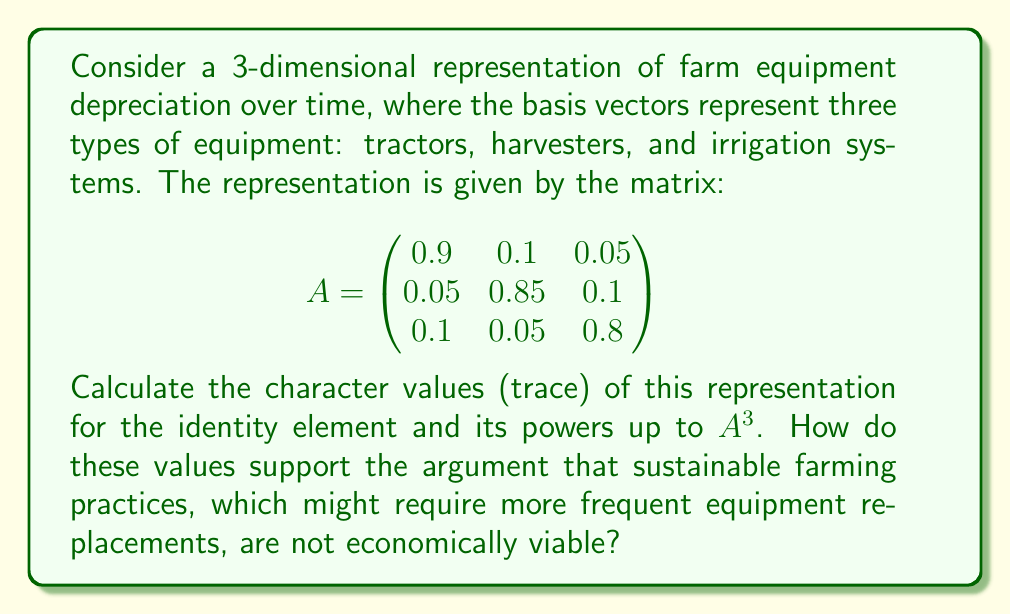Teach me how to tackle this problem. To calculate the character values, we need to find the trace of the matrix $A$ and its powers up to $A^3$. The trace is the sum of the elements on the main diagonal.

Step 1: Calculate $\text{Tr}(A)$
$$\text{Tr}(A) = 0.9 + 0.85 + 0.8 = 2.55$$

Step 2: Calculate $A^2$
$$A^2 = \begin{pmatrix}
0.9 & 0.1 & 0.05 \\
0.05 & 0.85 & 0.1 \\
0.1 & 0.05 & 0.8
\end{pmatrix} \times \begin{pmatrix}
0.9 & 0.1 & 0.05 \\
0.05 & 0.85 & 0.1 \\
0.1 & 0.05 & 0.8
\end{pmatrix}$$

$$A^2 = \begin{pmatrix}
0.8175 & 0.1775 & 0.1 \\
0.0925 & 0.7325 & 0.17 \\
0.175 & 0.0925 & 0.655
\end{pmatrix}$$

Step 3: Calculate $\text{Tr}(A^2)$
$$\text{Tr}(A^2) = 0.8175 + 0.7325 + 0.655 = 2.205$$

Step 4: Calculate $A^3$
$$A^3 = A \times A^2 = \begin{pmatrix}
0.74575 & 0.23925 & 0.14 \\
0.12825 & 0.63425 & 0.225 \\
0.2325 & 0.12825 & 0.535
\end{pmatrix}$$

Step 5: Calculate $\text{Tr}(A^3)$
$$\text{Tr}(A^3) = 0.74575 + 0.63425 + 0.535 = 1.915$$

These character values show a decreasing trend (2.55 → 2.205 → 1.915), indicating that the overall value of the farm equipment is decreasing over time. This supports the argument that sustainable farming practices, which might require more frequent equipment replacements, are not economically viable. The rapid depreciation of equipment value suggests that frequent replacements would lead to significant financial losses for farmers.
Answer: Character values: $\text{Tr}(A) = 2.55$, $\text{Tr}(A^2) = 2.205$, $\text{Tr}(A^3) = 1.915$ 